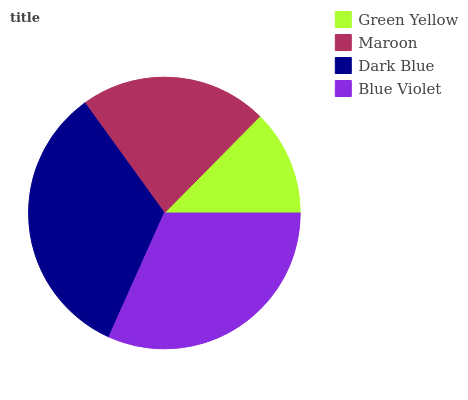Is Green Yellow the minimum?
Answer yes or no. Yes. Is Dark Blue the maximum?
Answer yes or no. Yes. Is Maroon the minimum?
Answer yes or no. No. Is Maroon the maximum?
Answer yes or no. No. Is Maroon greater than Green Yellow?
Answer yes or no. Yes. Is Green Yellow less than Maroon?
Answer yes or no. Yes. Is Green Yellow greater than Maroon?
Answer yes or no. No. Is Maroon less than Green Yellow?
Answer yes or no. No. Is Blue Violet the high median?
Answer yes or no. Yes. Is Maroon the low median?
Answer yes or no. Yes. Is Dark Blue the high median?
Answer yes or no. No. Is Dark Blue the low median?
Answer yes or no. No. 